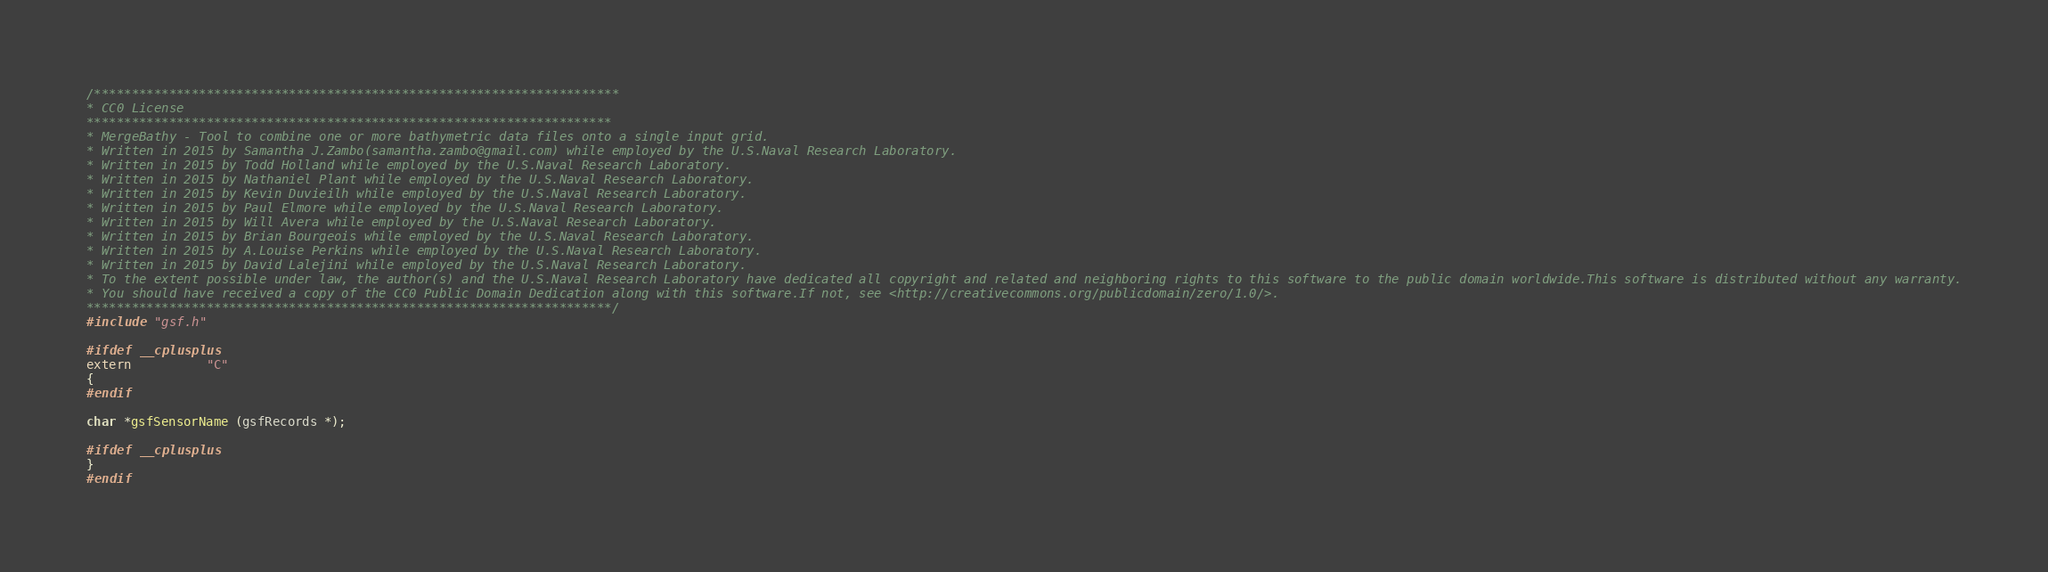<code> <loc_0><loc_0><loc_500><loc_500><_C_>/**********************************************************************
* CC0 License
**********************************************************************
* MergeBathy - Tool to combine one or more bathymetric data files onto a single input grid.
* Written in 2015 by Samantha J.Zambo(samantha.zambo@gmail.com) while employed by the U.S.Naval Research Laboratory.
* Written in 2015 by Todd Holland while employed by the U.S.Naval Research Laboratory.
* Written in 2015 by Nathaniel Plant while employed by the U.S.Naval Research Laboratory.
* Written in 2015 by Kevin Duvieilh while employed by the U.S.Naval Research Laboratory.
* Written in 2015 by Paul Elmore while employed by the U.S.Naval Research Laboratory.
* Written in 2015 by Will Avera while employed by the U.S.Naval Research Laboratory.
* Written in 2015 by Brian Bourgeois while employed by the U.S.Naval Research Laboratory.
* Written in 2015 by A.Louise Perkins while employed by the U.S.Naval Research Laboratory.
* Written in 2015 by David Lalejini while employed by the U.S.Naval Research Laboratory.
* To the extent possible under law, the author(s) and the U.S.Naval Research Laboratory have dedicated all copyright and related and neighboring rights to this software to the public domain worldwide.This software is distributed without any warranty.
* You should have received a copy of the CC0 Public Domain Dedication along with this software.If not, see <http://creativecommons.org/publicdomain/zero/1.0/>.
**********************************************************************/
#include "gsf.h"

#ifdef __cplusplus
extern          "C"
{
#endif

char *gsfSensorName (gsfRecords *);

#ifdef __cplusplus
}
#endif

</code> 